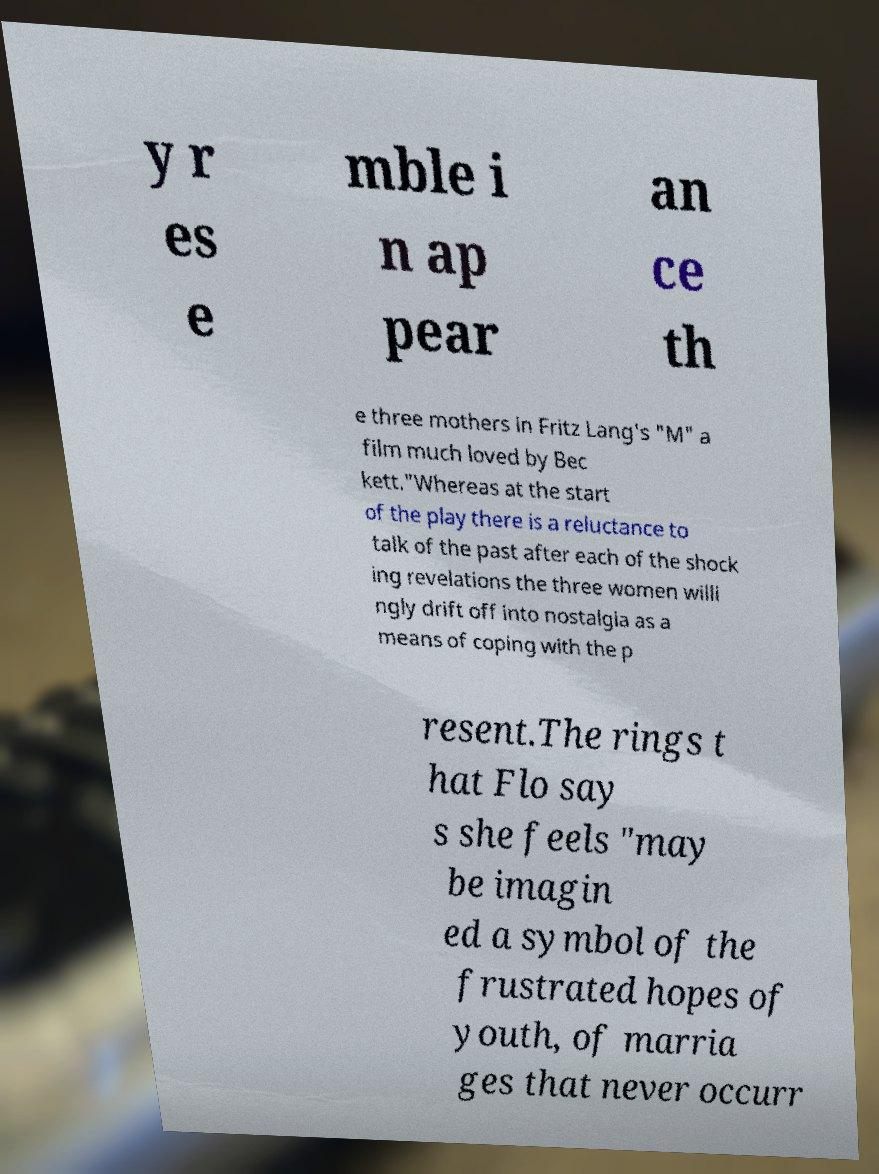What messages or text are displayed in this image? I need them in a readable, typed format. y r es e mble i n ap pear an ce th e three mothers in Fritz Lang's "M" a film much loved by Bec kett."Whereas at the start of the play there is a reluctance to talk of the past after each of the shock ing revelations the three women willi ngly drift off into nostalgia as a means of coping with the p resent.The rings t hat Flo say s she feels "may be imagin ed a symbol of the frustrated hopes of youth, of marria ges that never occurr 